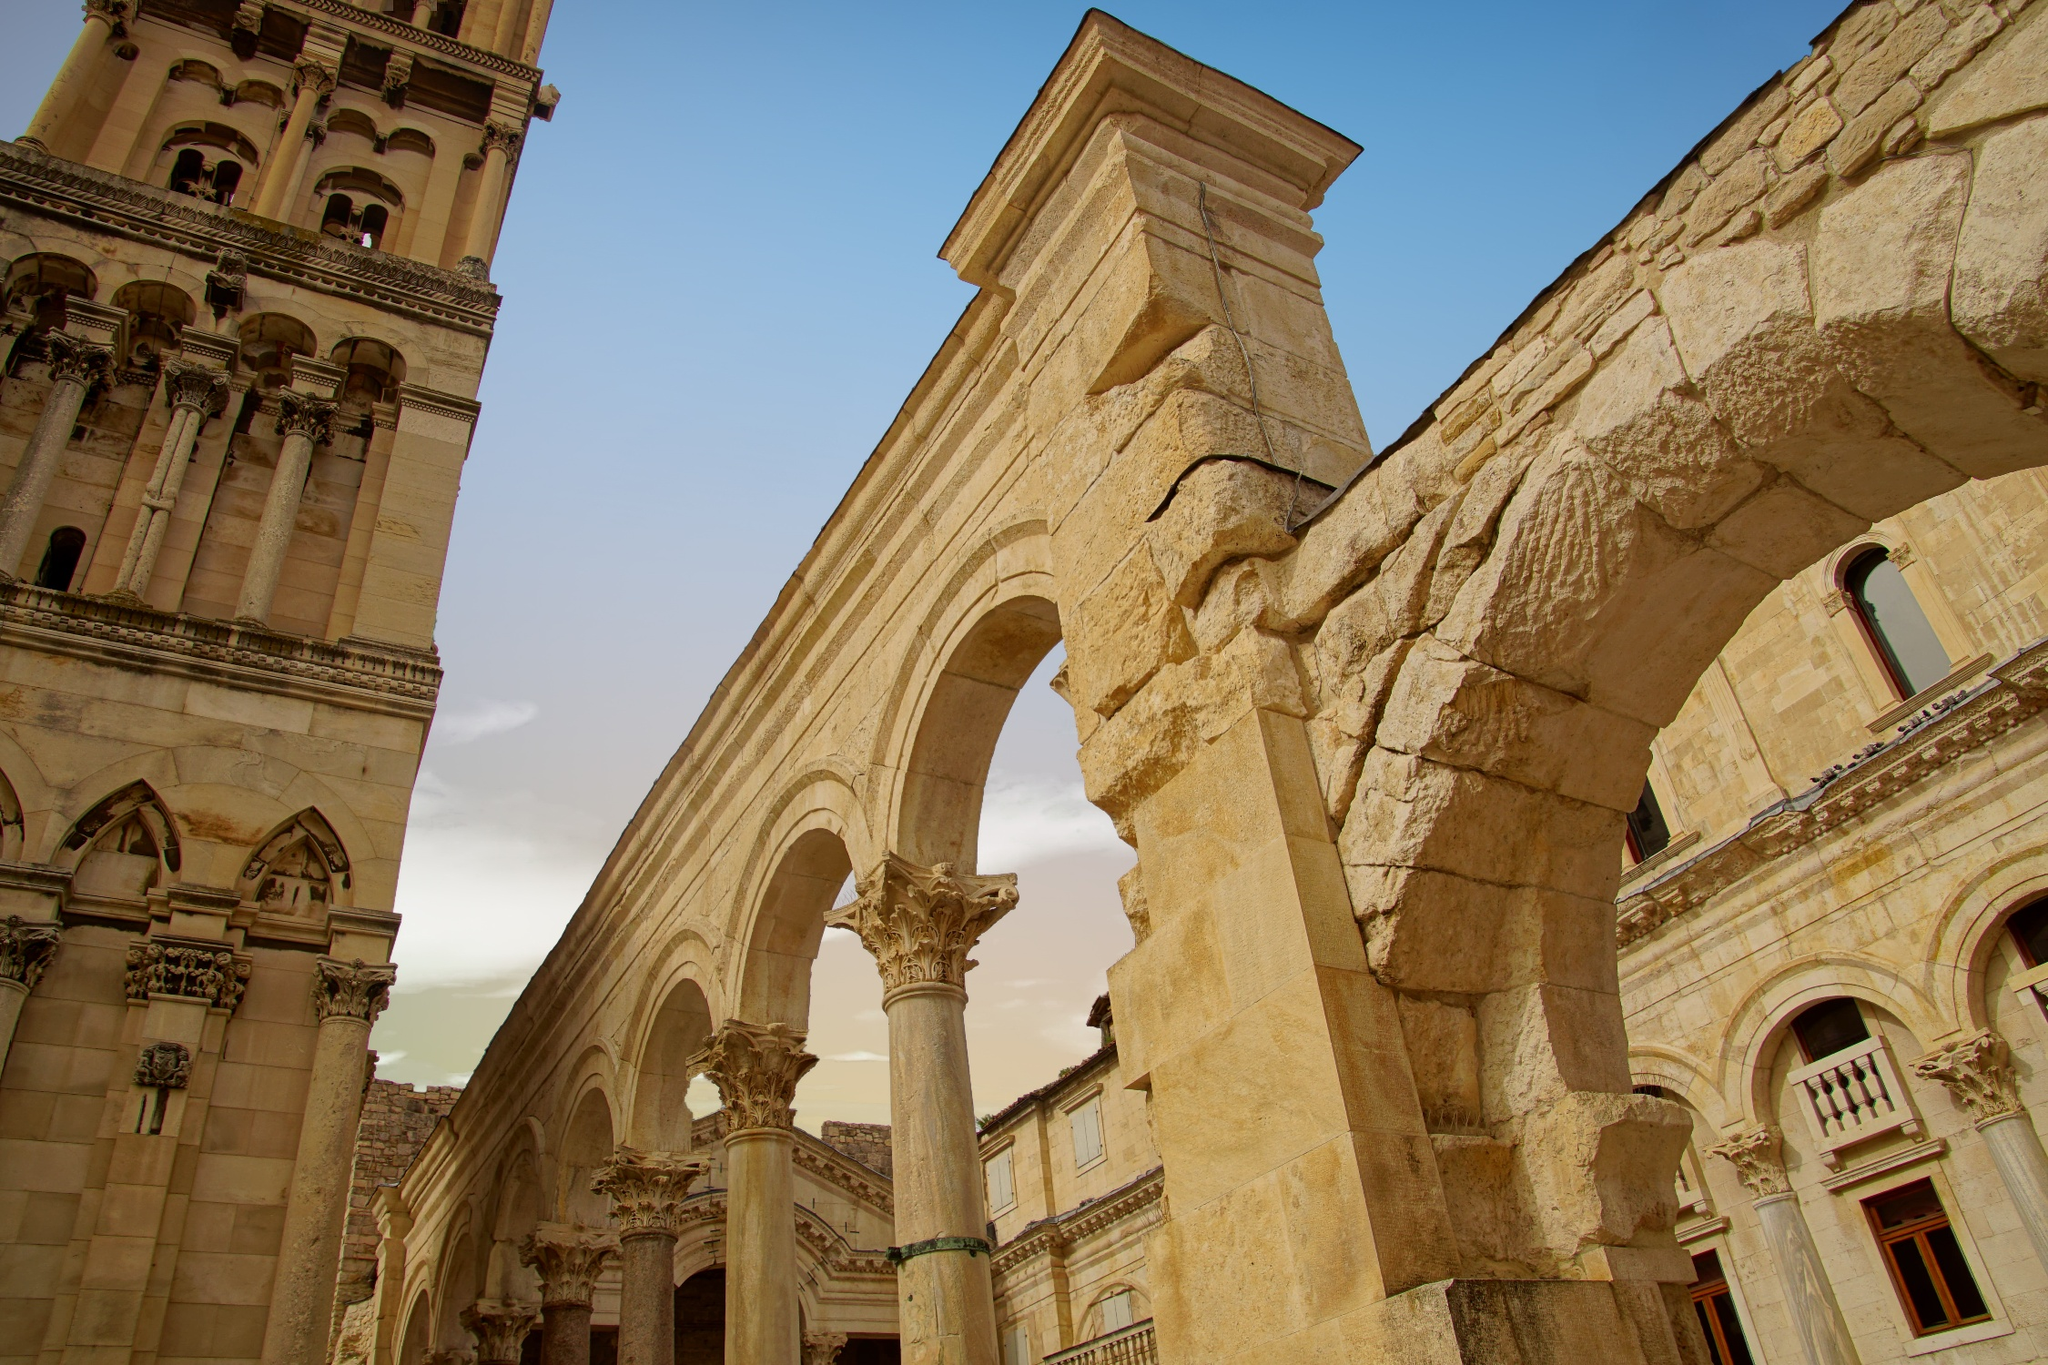Explain the visual content of the image in great detail. The image beautifully showcases a section of Diocletian's Palace in Split, Croatia. Captured from a low-angle perspective, the photo emphasizes the towering height of the palace's architectural elements, making them appear even more majestic. The main features are the grand arches and columns made of white stone, their intricate carvings highlighting the exquisite craftsmanship of the Roman era. These structures dominate the frame, leading the viewer's eye upward where the clear blue sky serves as a contrasting backdrop. The lighting is natural and bright, suggesting the photo was taken during the day. This setting accentuates the details of the stonework. In the background, a segment of the palace's facade is visible, adorned with arched windows and additional decorative stonework, enhancing the historical ambiance of the image. 